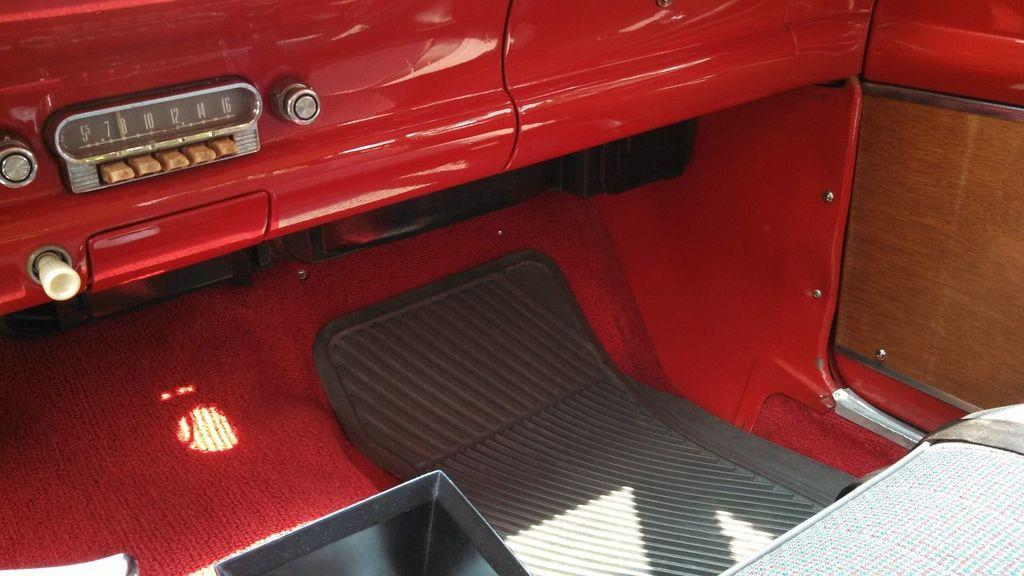Where was the image taken? The image was taken inside a vehicle. What can be seen inside the vehicle? There is a seat visible in the image. What is the color of the vehicle? The vehicle is red in color. How many beds are visible in the image? There are no beds visible in the image, as it was taken inside a vehicle. 